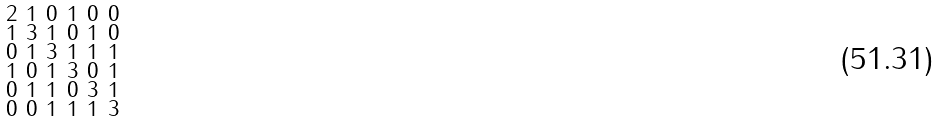Convert formula to latex. <formula><loc_0><loc_0><loc_500><loc_500>\begin{smallmatrix} 2 & 1 & 0 & 1 & 0 & 0 \\ 1 & 3 & 1 & 0 & 1 & 0 \\ 0 & 1 & 3 & 1 & 1 & 1 \\ 1 & 0 & 1 & 3 & 0 & 1 \\ 0 & 1 & 1 & 0 & 3 & 1 \\ 0 & 0 & 1 & 1 & 1 & 3 \end{smallmatrix}</formula> 